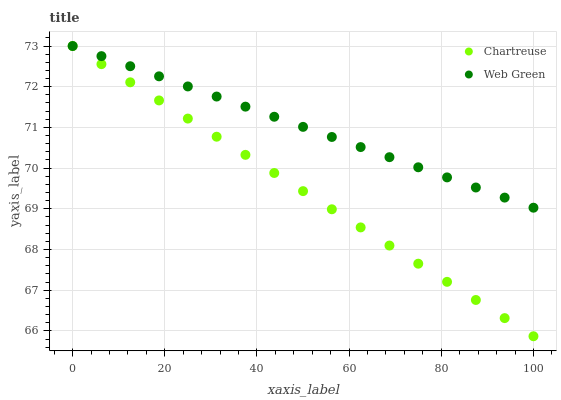Does Chartreuse have the minimum area under the curve?
Answer yes or no. Yes. Does Web Green have the maximum area under the curve?
Answer yes or no. Yes. Does Web Green have the minimum area under the curve?
Answer yes or no. No. Is Web Green the smoothest?
Answer yes or no. Yes. Is Chartreuse the roughest?
Answer yes or no. Yes. Is Web Green the roughest?
Answer yes or no. No. Does Chartreuse have the lowest value?
Answer yes or no. Yes. Does Web Green have the lowest value?
Answer yes or no. No. Does Web Green have the highest value?
Answer yes or no. Yes. Does Chartreuse intersect Web Green?
Answer yes or no. Yes. Is Chartreuse less than Web Green?
Answer yes or no. No. Is Chartreuse greater than Web Green?
Answer yes or no. No. 